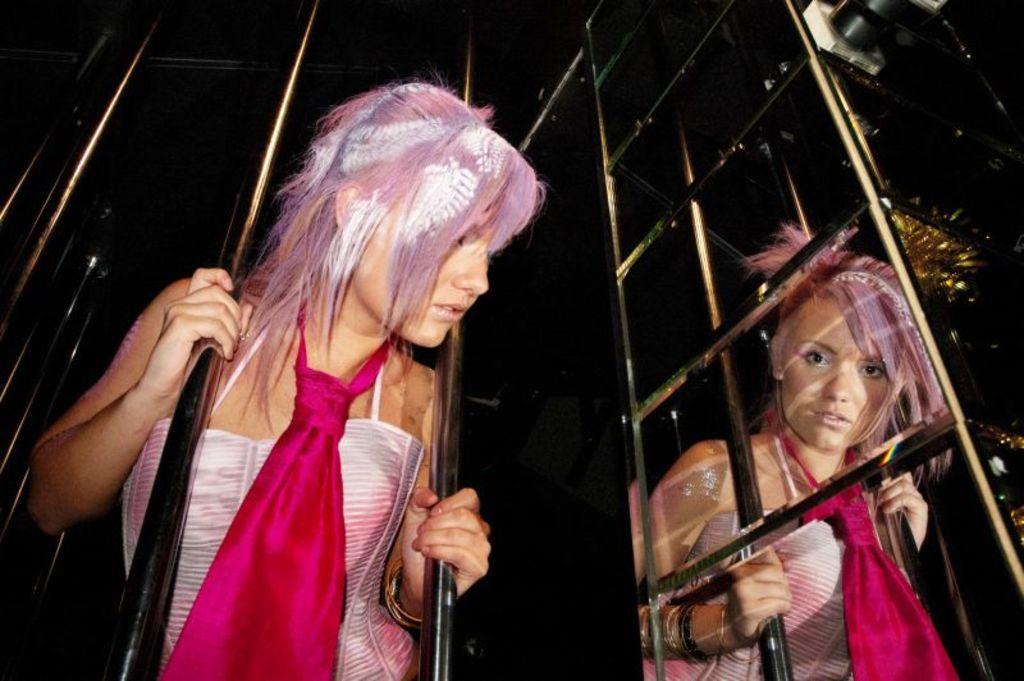Describe this image in one or two sentences. In this image I can see a woman visible in between two rods and I can see another woman visible in front of fence, on the right side there are some rods visible. 